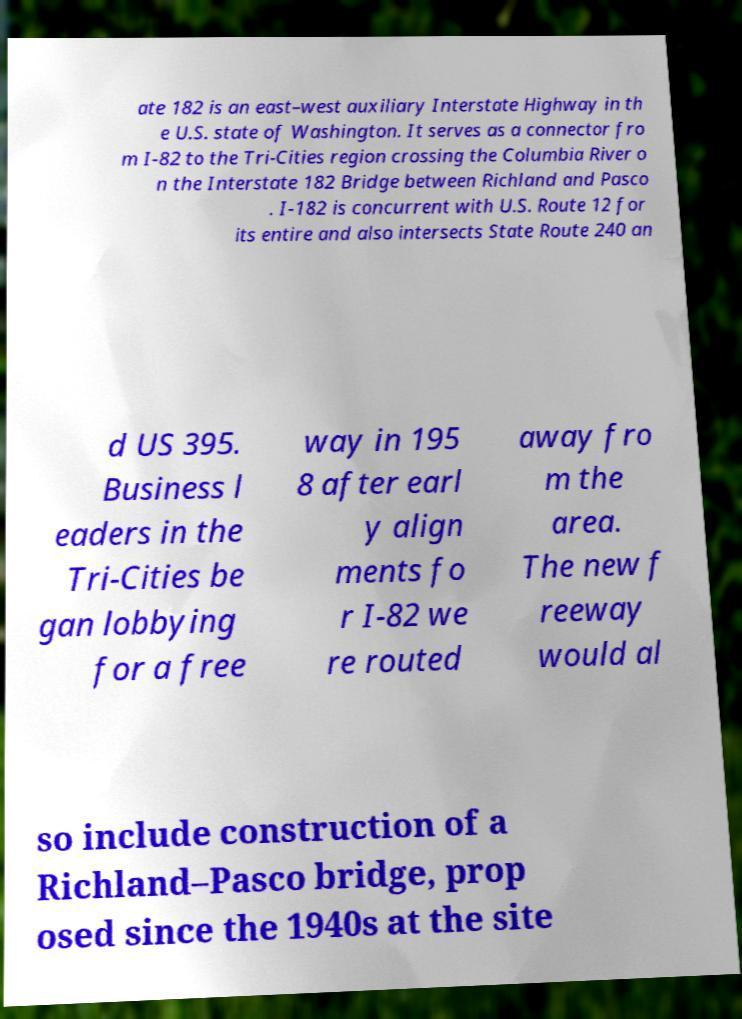Please identify and transcribe the text found in this image. ate 182 is an east–west auxiliary Interstate Highway in th e U.S. state of Washington. It serves as a connector fro m I-82 to the Tri-Cities region crossing the Columbia River o n the Interstate 182 Bridge between Richland and Pasco . I-182 is concurrent with U.S. Route 12 for its entire and also intersects State Route 240 an d US 395. Business l eaders in the Tri-Cities be gan lobbying for a free way in 195 8 after earl y align ments fo r I-82 we re routed away fro m the area. The new f reeway would al so include construction of a Richland–Pasco bridge, prop osed since the 1940s at the site 